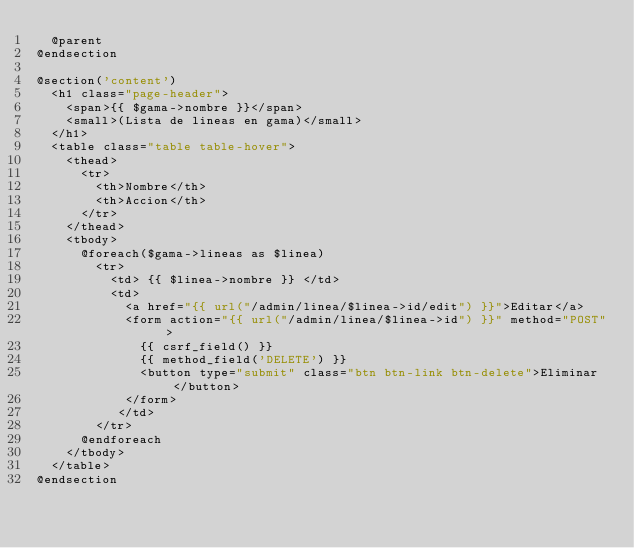Convert code to text. <code><loc_0><loc_0><loc_500><loc_500><_PHP_>	@parent
@endsection

@section('content')
	<h1 class="page-header">
		<span>{{ $gama->nombre }}</span>
		<small>(Lista de lineas en gama)</small>
	</h1>
	<table class="table table-hover">
		<thead>
			<tr>
				<th>Nombre</th>
				<th>Accion</th>
			</tr>
		</thead>
		<tbody>
			@foreach($gama->lineas as $linea)
				<tr>
					<td> {{ $linea->nombre }} </td>
					<td> 
						<a href="{{ url("/admin/linea/$linea->id/edit") }}">Editar</a>
						<form action="{{ url("/admin/linea/$linea->id") }}" method="POST" >
							{{ csrf_field() }}
							{{ method_field('DELETE') }}
			      	<button type="submit" class="btn btn-link btn-delete">Eliminar</button>
			      </form>
					 </td>
				</tr>
			@endforeach
		</tbody>
	</table>
@endsection
</code> 